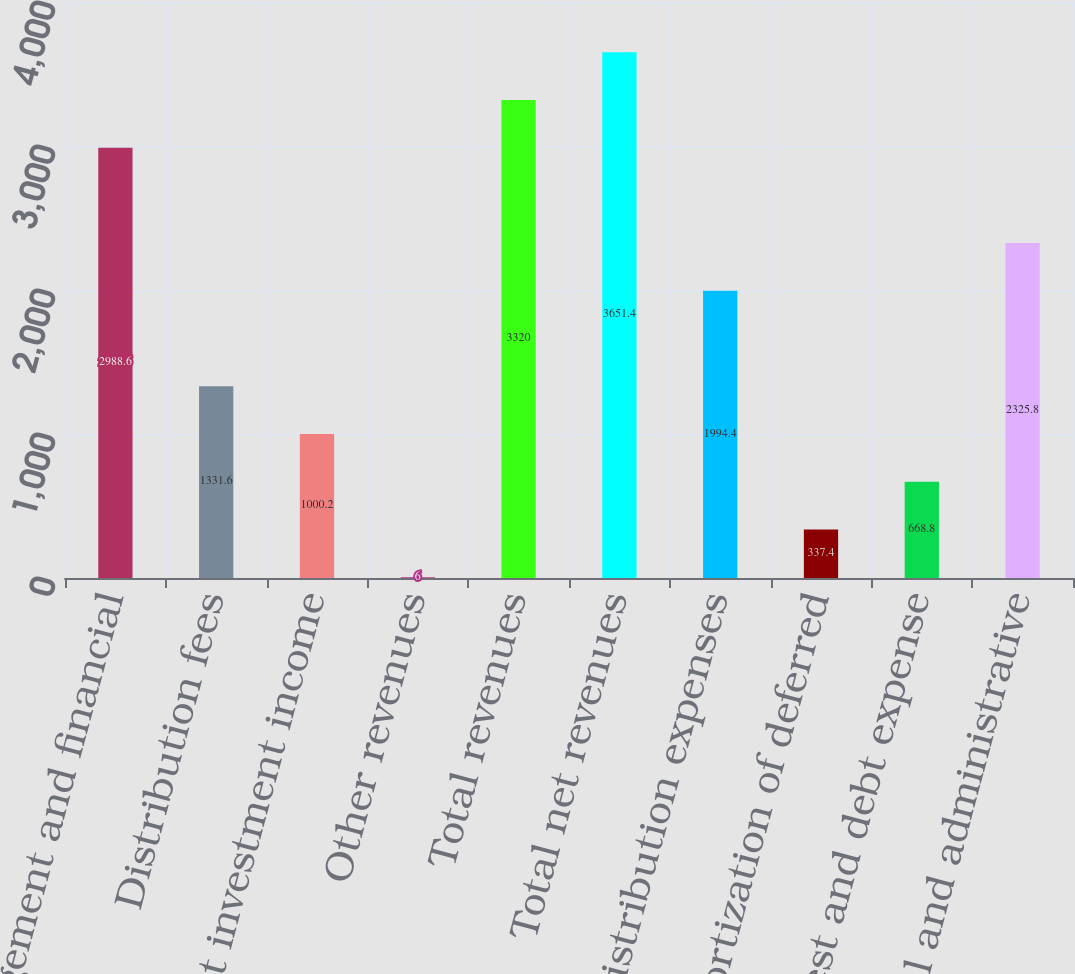Convert chart to OTSL. <chart><loc_0><loc_0><loc_500><loc_500><bar_chart><fcel>Management and financial<fcel>Distribution fees<fcel>Net investment income<fcel>Other revenues<fcel>Total revenues<fcel>Total net revenues<fcel>Distribution expenses<fcel>Amortization of deferred<fcel>Interest and debt expense<fcel>General and administrative<nl><fcel>2988.6<fcel>1331.6<fcel>1000.2<fcel>6<fcel>3320<fcel>3651.4<fcel>1994.4<fcel>337.4<fcel>668.8<fcel>2325.8<nl></chart> 